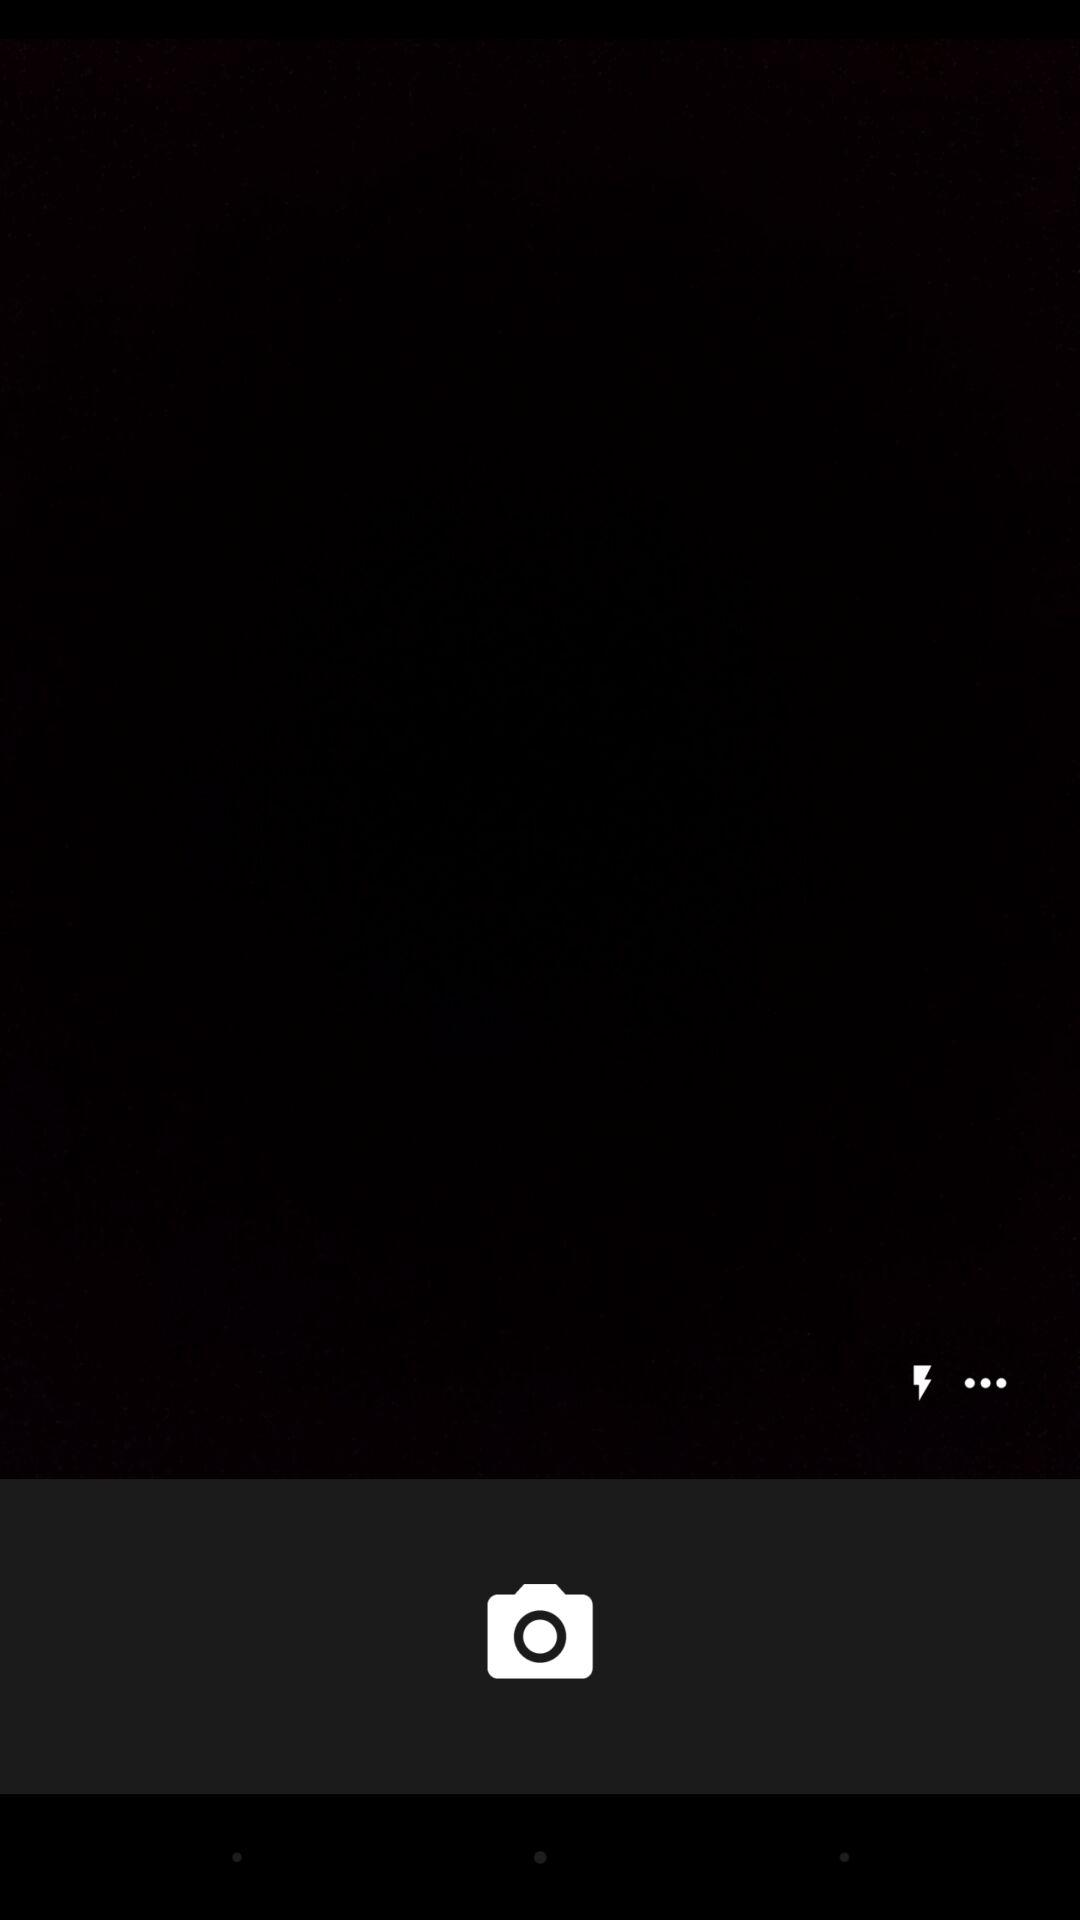How many more dots are there than lightning bolts?
Answer the question using a single word or phrase. 2 